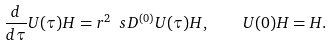Convert formula to latex. <formula><loc_0><loc_0><loc_500><loc_500>\frac { d } { d \tau } U ( \tau ) H = r ^ { 2 } \ s D ^ { ( 0 ) } U ( \tau ) H , \quad U ( 0 ) H = H .</formula> 